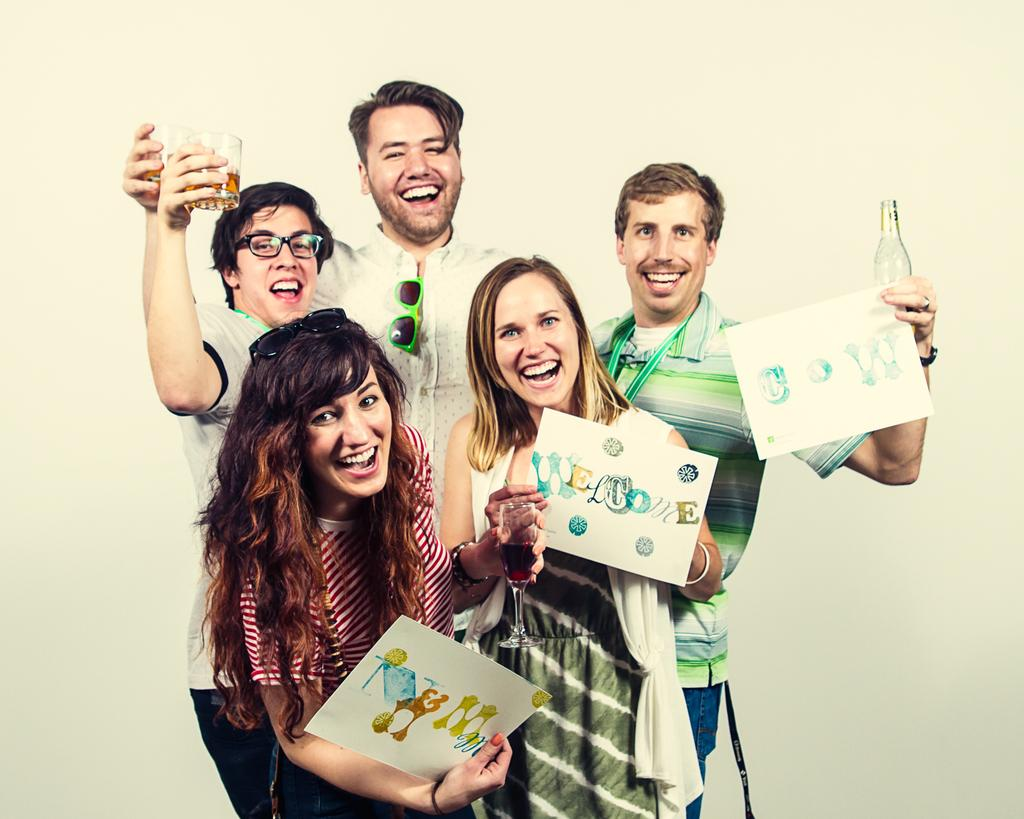How many people are in the image? There are three men and two women in the image, making a total of five people. What are the individuals doing in the image? The individuals are standing and holding glasses. Are any of them holding additional items? Yes, three of them are holding papers. What is the general mood of the people in the image? All of them are smiling, indicating a positive or happy mood. What type of cheese can be seen in the image? There is no cheese present in the image. How many caves are visible in the background of the image? There are no caves visible in the image; it features a group of people standing and holding glasses. 